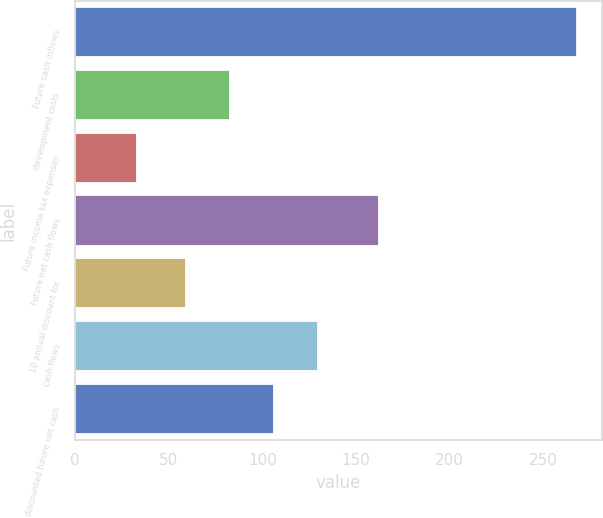Convert chart to OTSL. <chart><loc_0><loc_0><loc_500><loc_500><bar_chart><fcel>Future cash inflows<fcel>development costs<fcel>Future income tax expenses<fcel>Future net cash flows<fcel>10 annual discount for<fcel>cash flows<fcel>discounted future net cash<nl><fcel>268<fcel>82.5<fcel>33<fcel>162<fcel>59<fcel>129.5<fcel>106<nl></chart> 